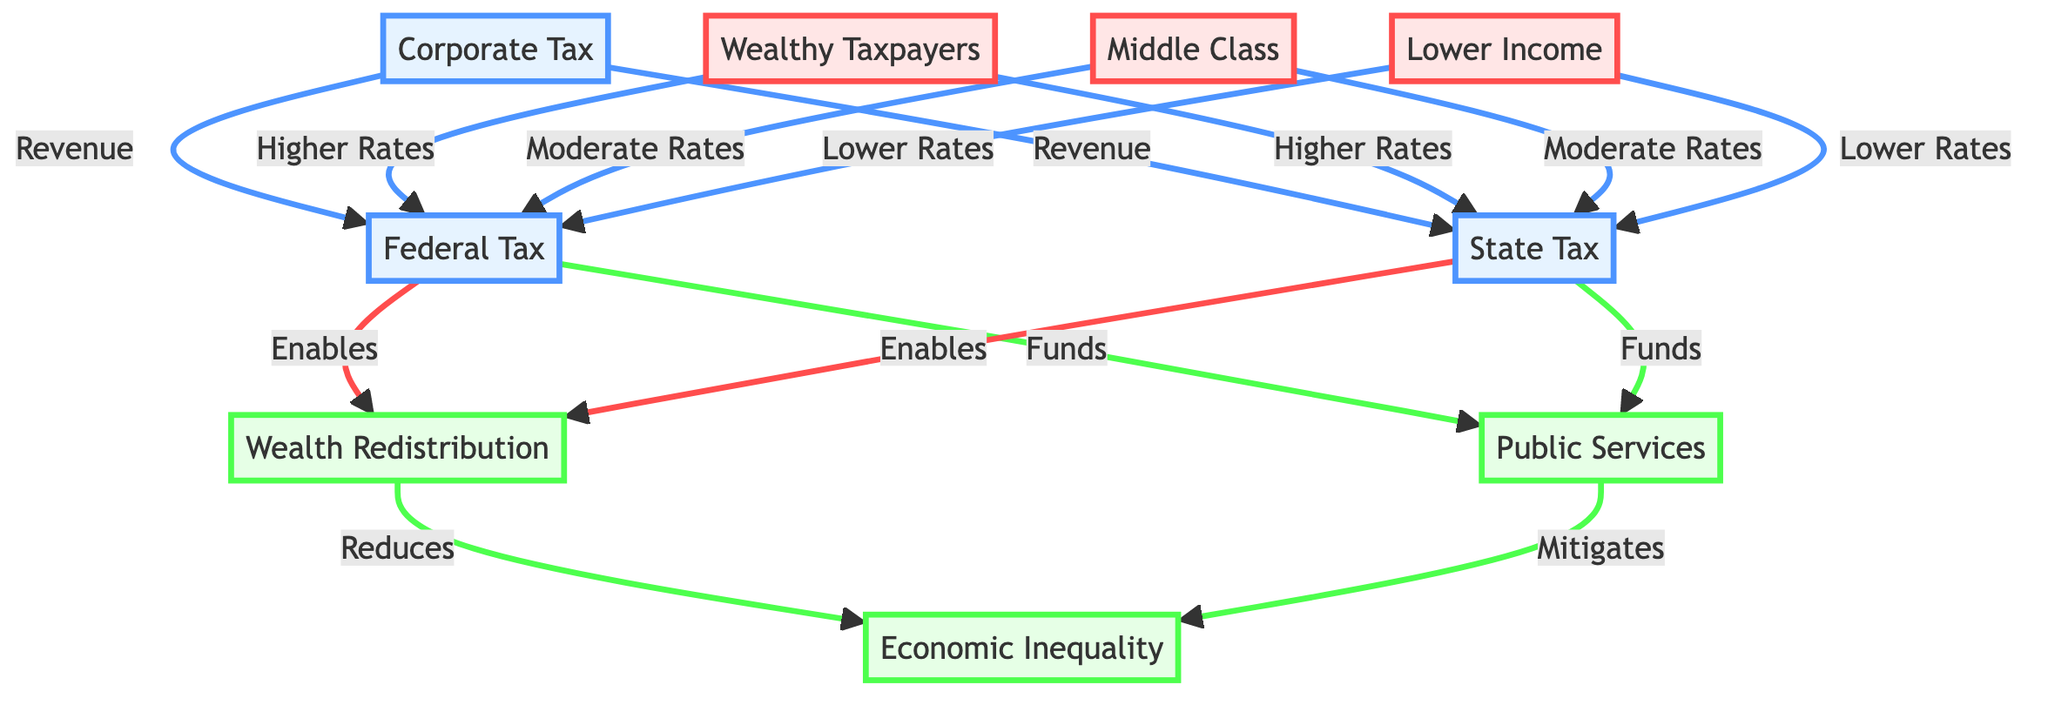What is the primary outcome enabled by federal tax? In the diagram, there is a directed edge labeled "Enables" connecting federal tax to wealth redistribution, indicating that federal tax allows for or facilitates wealth redistribution as an outcome.
Answer: Wealth Redistribution How do lower-income taxpayers contribute to state tax rates? The diagram shows that lower-income taxpayers are connected to state tax with a directed edge labeled "Lower Rates," which means they pay lower tax rates compared to other groups in the diagram.
Answer: Lower Rates What type of taxpayers contribute to both federal and state taxes at higher rates? The diagram connects wealthy taxpayers to both federal tax and state tax with directed edges stating "Higher Rates," indicating that this socioeconomic group pays higher rates of taxation in these categories.
Answer: Wealthy Taxpayers What is the connection between public services and economic inequality? The diagram includes two directed edges, with public services mitigating economic inequality, meaning that funding from taxes helps reduce the disparity between different income levels.
Answer: Mitigates How many socioeconomic classes are represented in the diagram? The diagram includes three distinct socioeconomic classes: wealthy taxpayers, middle class, and lower income, leading to a total of three classes present in the visual representation.
Answer: Three 